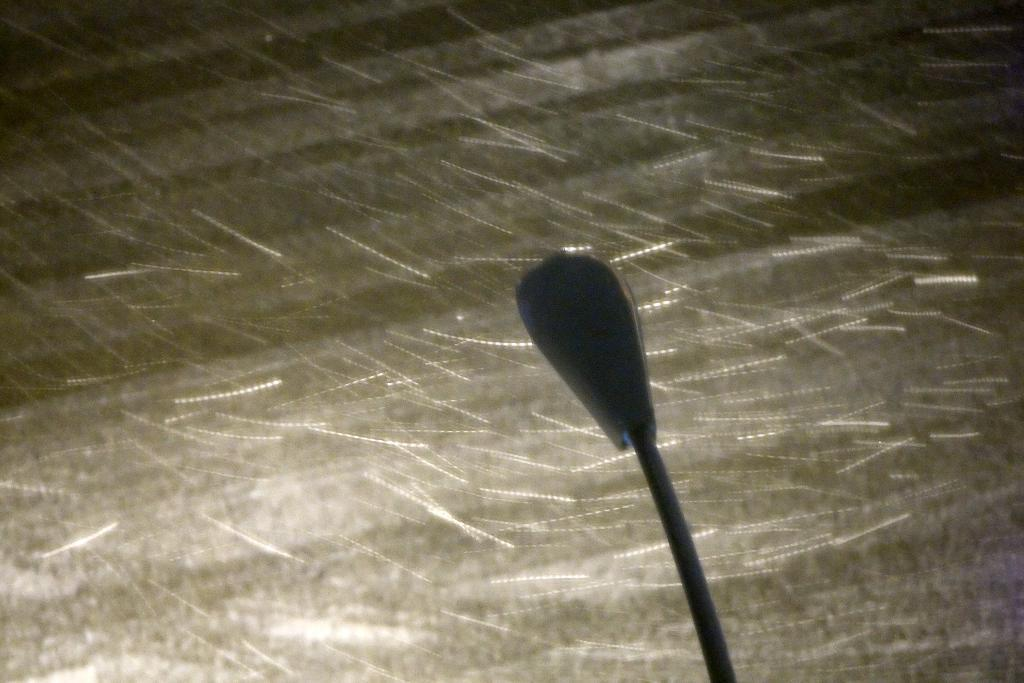What is the main object in the image? There is a light pole in the image. What is the color of the background in the image? The background of the image is black. Can you describe any other objects in the image? There are blurry objects in the image. What type of sofa can be seen in the image? There is no sofa present in the image. What knowledge is being shared in the image? The image does not depict any knowledge being shared; it features a light pole and a black background. 